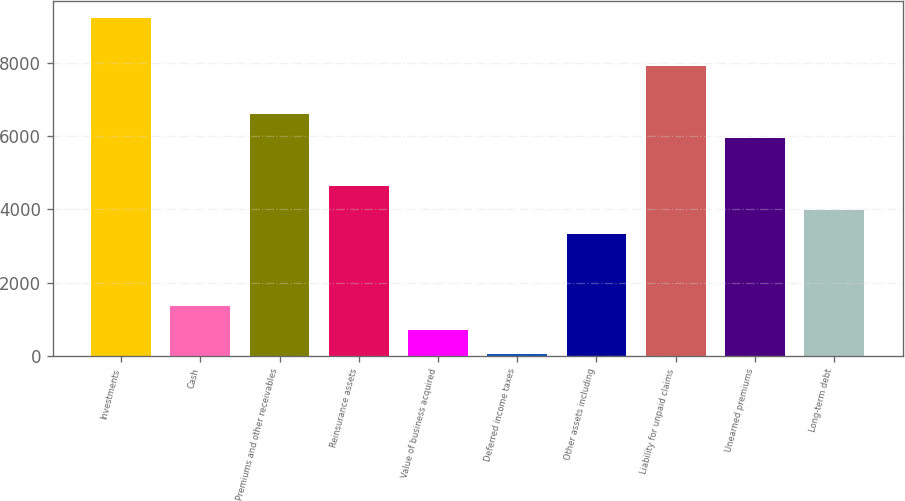Convert chart to OTSL. <chart><loc_0><loc_0><loc_500><loc_500><bar_chart><fcel>Investments<fcel>Cash<fcel>Premiums and other receivables<fcel>Reinsurance assets<fcel>Value of business acquired<fcel>Deferred income taxes<fcel>Other assets including<fcel>Liability for unpaid claims<fcel>Unearned premiums<fcel>Long-term debt<nl><fcel>9233<fcel>1373<fcel>6613<fcel>4648<fcel>718<fcel>63<fcel>3338<fcel>7923<fcel>5958<fcel>3993<nl></chart> 